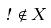<formula> <loc_0><loc_0><loc_500><loc_500>\omega \notin X</formula> 